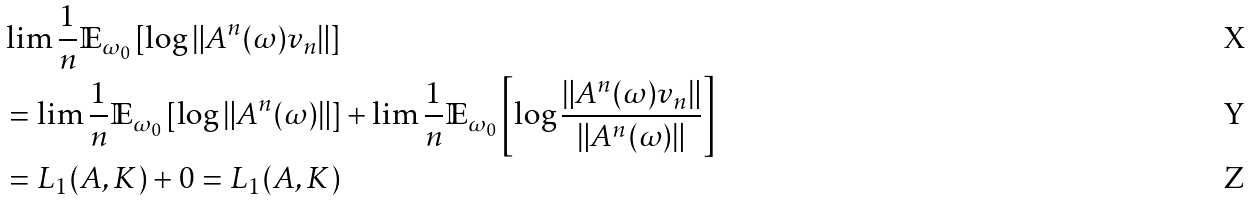Convert formula to latex. <formula><loc_0><loc_0><loc_500><loc_500>& \lim \frac { 1 } { n } \mathbb { E } _ { \omega _ { 0 } } \left [ \log \| A ^ { n } ( \omega ) v _ { n } \| \right ] \\ & = \lim \frac { 1 } { n } \mathbb { E } _ { \omega _ { 0 } } \left [ \log \| A ^ { n } ( \omega ) \| \right ] + \lim \frac { 1 } { n } \mathbb { E } _ { \omega _ { 0 } } \left [ \log \frac { \| A ^ { n } ( \omega ) v _ { n } \| } { \| A ^ { n } ( \omega ) \| } \right ] \\ & = L _ { 1 } ( A , K ) + 0 = L _ { 1 } ( A , K )</formula> 